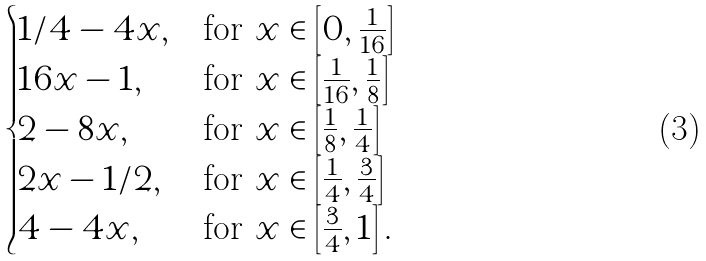<formula> <loc_0><loc_0><loc_500><loc_500>\begin{cases} 1 / 4 - 4 x , & \text {for} \ x \in \left [ 0 , \frac { 1 } { 1 6 } \right ] \\ 1 6 x - 1 , & \text {for} \ x \in \left [ \frac { 1 } { 1 6 } , \frac { 1 } { 8 } \right ] \\ 2 - 8 x , & \text {for} \ x \in \left [ \frac { 1 } { 8 } , \frac { 1 } { 4 } \right ] \\ 2 x - 1 / 2 , & \text {for} \ x \in \left [ \frac { 1 } { 4 } , \frac { 3 } { 4 } \right ] \\ 4 - 4 x , & \text {for} \ x \in \left [ \frac { 3 } { 4 } , 1 \right ] . \end{cases}</formula> 